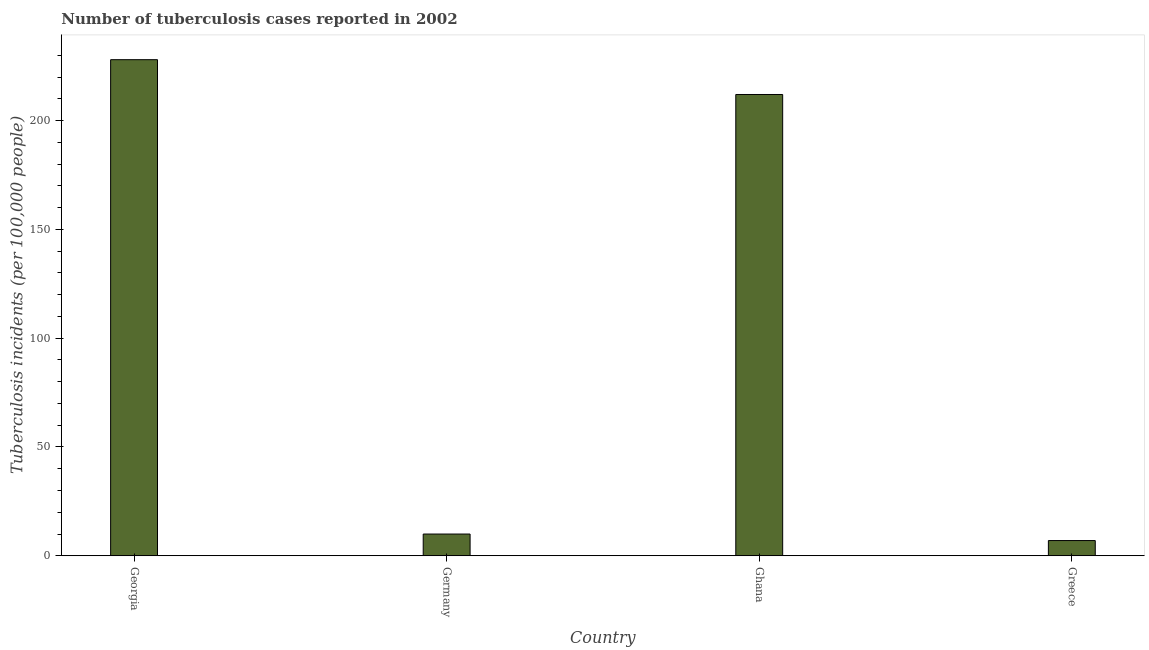Does the graph contain any zero values?
Your answer should be compact. No. What is the title of the graph?
Make the answer very short. Number of tuberculosis cases reported in 2002. What is the label or title of the X-axis?
Your answer should be compact. Country. What is the label or title of the Y-axis?
Make the answer very short. Tuberculosis incidents (per 100,0 people). What is the number of tuberculosis incidents in Ghana?
Make the answer very short. 212. Across all countries, what is the maximum number of tuberculosis incidents?
Your answer should be compact. 228. Across all countries, what is the minimum number of tuberculosis incidents?
Offer a terse response. 7. In which country was the number of tuberculosis incidents maximum?
Offer a terse response. Georgia. In which country was the number of tuberculosis incidents minimum?
Provide a succinct answer. Greece. What is the sum of the number of tuberculosis incidents?
Ensure brevity in your answer.  457. What is the difference between the number of tuberculosis incidents in Georgia and Germany?
Ensure brevity in your answer.  218. What is the average number of tuberculosis incidents per country?
Offer a terse response. 114.25. What is the median number of tuberculosis incidents?
Your answer should be very brief. 111. What is the ratio of the number of tuberculosis incidents in Germany to that in Greece?
Keep it short and to the point. 1.43. Is the number of tuberculosis incidents in Georgia less than that in Ghana?
Provide a succinct answer. No. What is the difference between the highest and the second highest number of tuberculosis incidents?
Provide a short and direct response. 16. Is the sum of the number of tuberculosis incidents in Georgia and Ghana greater than the maximum number of tuberculosis incidents across all countries?
Ensure brevity in your answer.  Yes. What is the difference between the highest and the lowest number of tuberculosis incidents?
Your answer should be compact. 221. How many bars are there?
Provide a succinct answer. 4. What is the difference between two consecutive major ticks on the Y-axis?
Your response must be concise. 50. Are the values on the major ticks of Y-axis written in scientific E-notation?
Offer a very short reply. No. What is the Tuberculosis incidents (per 100,000 people) in Georgia?
Keep it short and to the point. 228. What is the Tuberculosis incidents (per 100,000 people) of Ghana?
Keep it short and to the point. 212. What is the Tuberculosis incidents (per 100,000 people) of Greece?
Ensure brevity in your answer.  7. What is the difference between the Tuberculosis incidents (per 100,000 people) in Georgia and Germany?
Offer a very short reply. 218. What is the difference between the Tuberculosis incidents (per 100,000 people) in Georgia and Greece?
Make the answer very short. 221. What is the difference between the Tuberculosis incidents (per 100,000 people) in Germany and Ghana?
Offer a very short reply. -202. What is the difference between the Tuberculosis incidents (per 100,000 people) in Ghana and Greece?
Your response must be concise. 205. What is the ratio of the Tuberculosis incidents (per 100,000 people) in Georgia to that in Germany?
Your answer should be very brief. 22.8. What is the ratio of the Tuberculosis incidents (per 100,000 people) in Georgia to that in Ghana?
Offer a very short reply. 1.07. What is the ratio of the Tuberculosis incidents (per 100,000 people) in Georgia to that in Greece?
Give a very brief answer. 32.57. What is the ratio of the Tuberculosis incidents (per 100,000 people) in Germany to that in Ghana?
Offer a terse response. 0.05. What is the ratio of the Tuberculosis incidents (per 100,000 people) in Germany to that in Greece?
Offer a very short reply. 1.43. What is the ratio of the Tuberculosis incidents (per 100,000 people) in Ghana to that in Greece?
Provide a succinct answer. 30.29. 